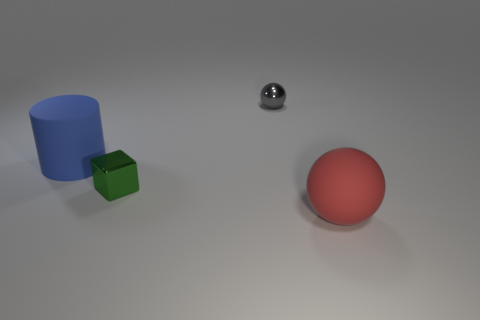Can you describe the lighting in the scene? The lighting in the image is diffuse, creating soft shadows on the ground behind each object. There's a sense of ambient light illuminating the scene from above, suggesting an indoor environment with either natural light filtering through or well-dispersed artificial lighting. Does the lighting affect the appearance of the objects? Yes, the diffused lighting highlights the contours of the objects and affects their color perception. The glossy objects reflect the light, accentuating their shine, whereas the matte objects absorb the light, which softens their appearance. 